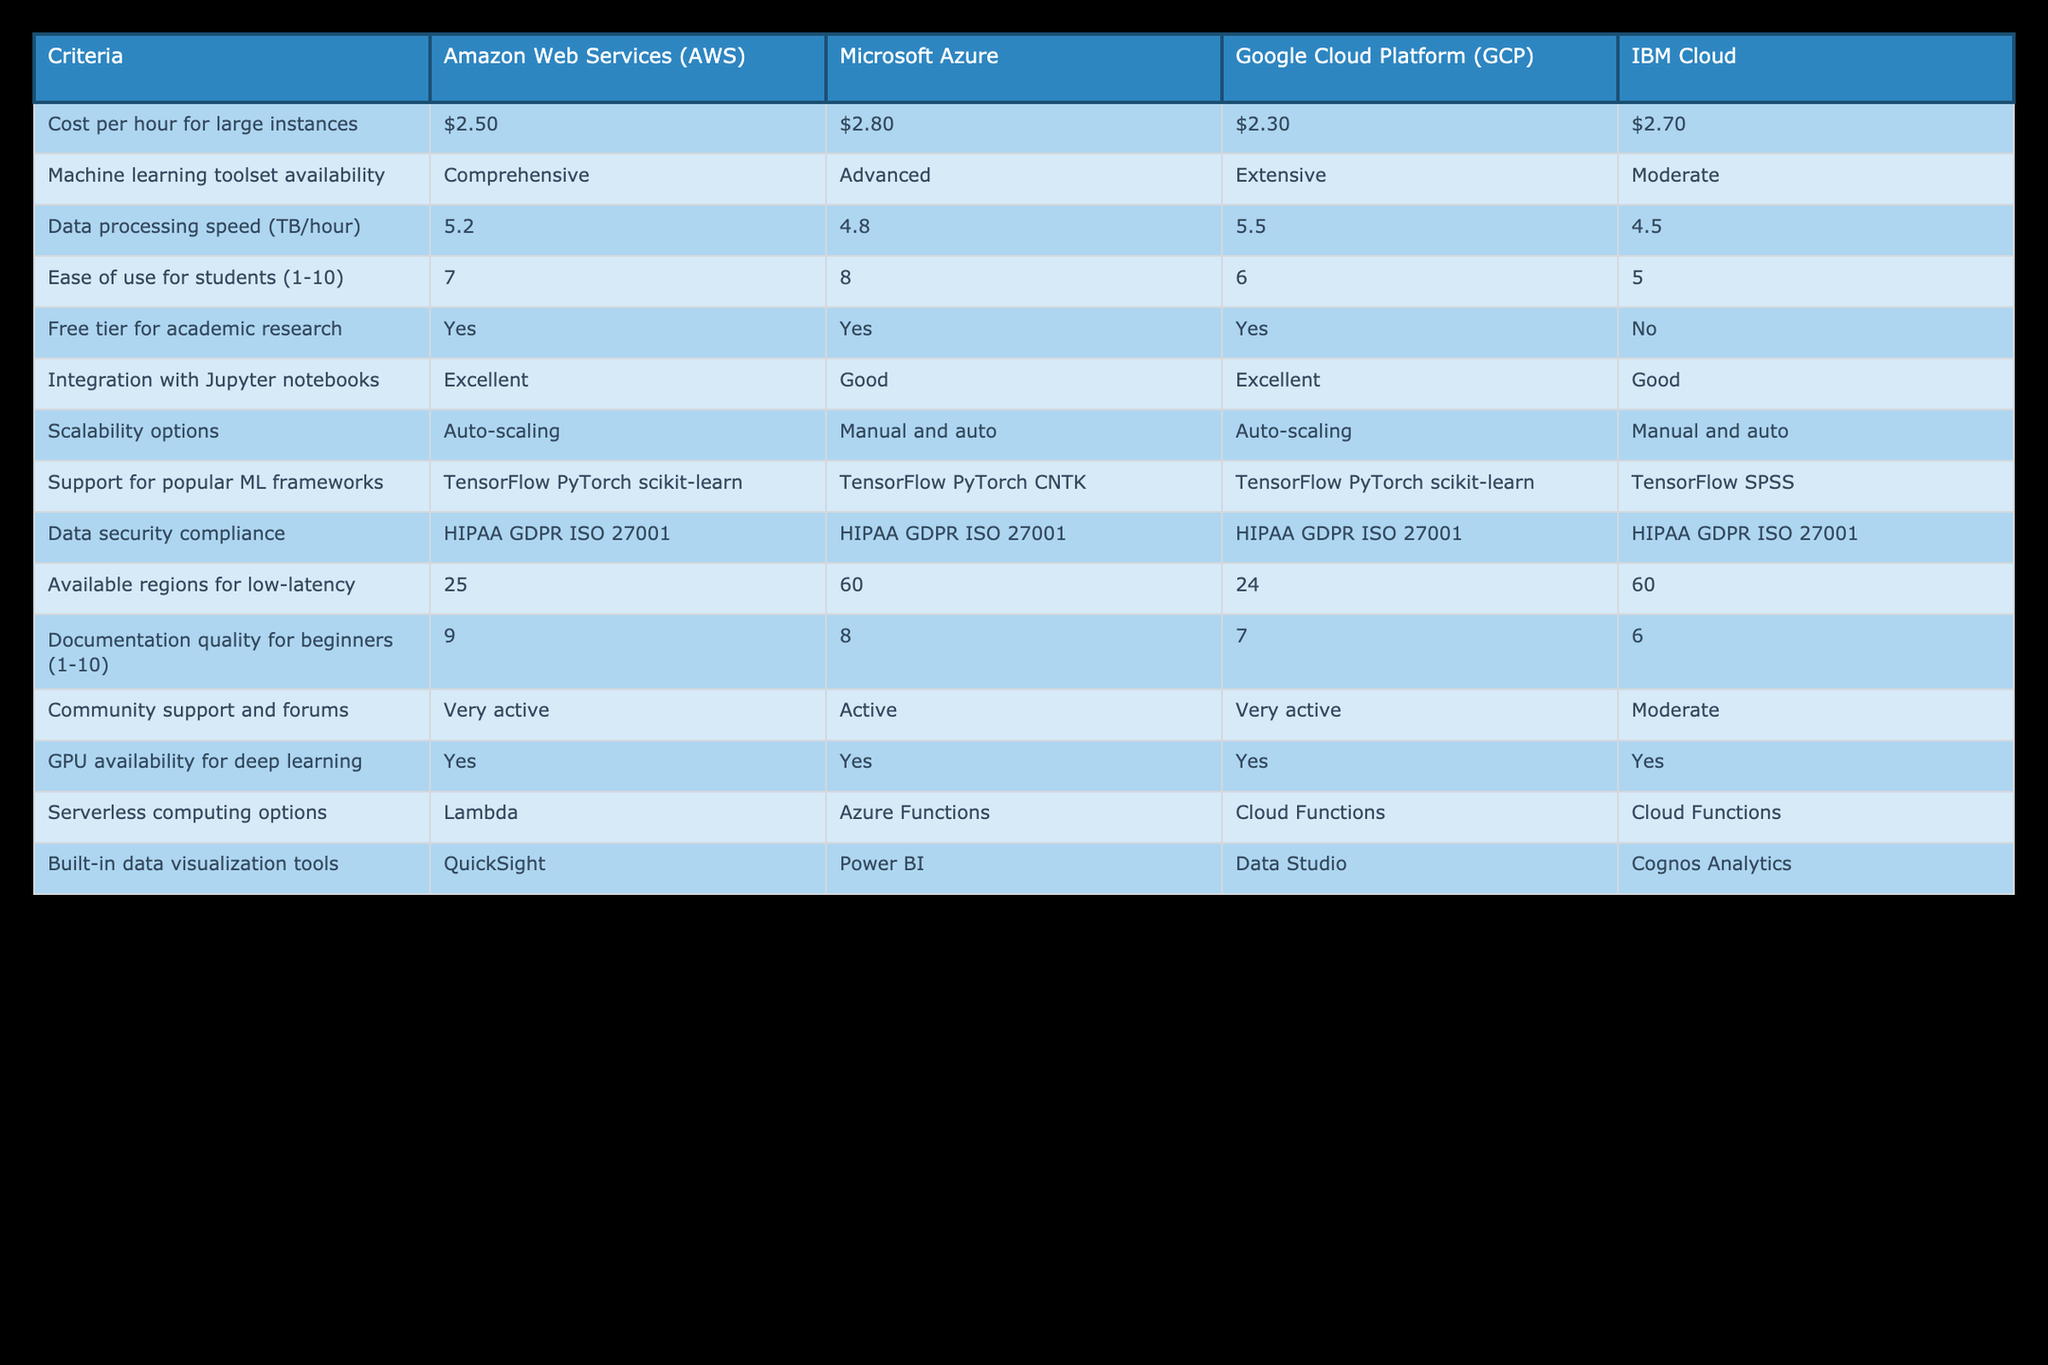What is the cost per hour for large instances in Google Cloud Platform? The table shows the cost per hour for large instances specifically listed under Google Cloud Platform, which is $2.30.
Answer: $2.30 Which platform has the highest data processing speed? By comparing the "Data processing speed (TB/hour)" values, Amazon Web Services has a speed of 5.2, Microsoft Azure has 4.8, Google Cloud Platform has 5.5, and IBM Cloud has 4.5. Google Cloud Platform has the highest at 5.5.
Answer: Google Cloud Platform Do all the platforms support serverless computing options? The table lists the serverless computing options for each platform: AWS has Lambda, Azure has Azure Functions, GCP has Cloud Functions, and IBM Cloud also has Cloud Functions. Therefore, all platforms do provide serverless computing options.
Answer: Yes What is the average ease of use score for the platforms listed? The ease of use scores are as follows: AWS is 7, Azure is 8, GCP is 6, and IBM Cloud is 5. Adding these scores gives a total of 26, and dividing by the number of platforms (4) gives an average of 6.5.
Answer: 6.5 Does IBM Cloud have a free tier for academic research? According to the table, IBM Cloud is marked as "No" for having a free tier for academic research, indicating that it does not offer this benefit.
Answer: No Which platform offers the best documentation quality for beginners? The documentation quality scores are 9 for AWS, 8 for Azure, 7 for GCP, and 6 for IBM Cloud. AWS has the highest score of 9, indicating it offers the best documentation quality for beginners.
Answer: AWS Which platform has the most available regions for low latency? The table specifies that AWS has 25 regions, Azure has 60, GCP has 24, and IBM Cloud has 60. Both Microsoft Azure and IBM Cloud have the maximum number of available regions, which is 60.
Answer: Azure and IBM Cloud If a student needs extensive community support, which platforms should they consider? The table indicates community support levels: AWS and GCP are rated as "Very active," Azure as "Active," and IBM Cloud as "Moderate." Therefore, the student should consider AWS and GCP for extensive community support.
Answer: AWS and GCP What is the difference in cost per hour between AWS and Azure for large instances? The cost per hour for AWS is $2.50, and for Azure, it is $2.80. The difference between these two costs is calculated as follows: $2.80 - $2.50 = $0.30.
Answer: $0.30 